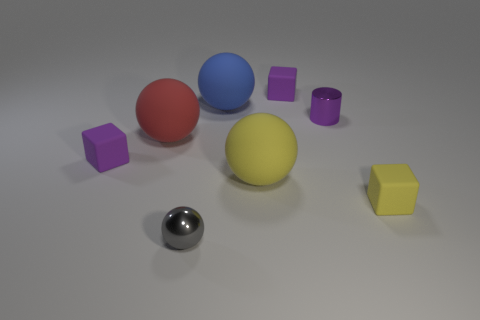Subtract all yellow balls. How many balls are left? 3 Subtract all yellow rubber spheres. How many spheres are left? 3 Subtract all cyan balls. Subtract all gray blocks. How many balls are left? 4 Add 2 tiny gray things. How many objects exist? 10 Subtract all cubes. How many objects are left? 5 Add 3 tiny purple cubes. How many tiny purple cubes are left? 5 Add 6 tiny gray shiny balls. How many tiny gray shiny balls exist? 7 Subtract 0 gray blocks. How many objects are left? 8 Subtract all tiny blue metallic things. Subtract all big yellow rubber balls. How many objects are left? 7 